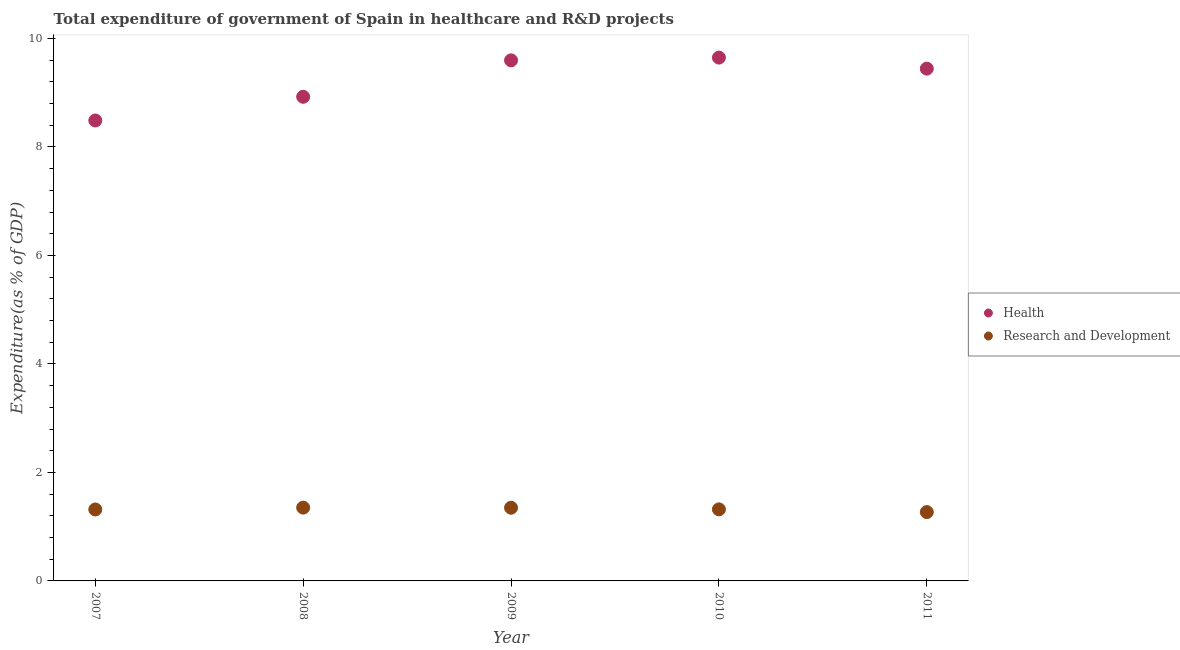What is the expenditure in healthcare in 2010?
Provide a succinct answer. 9.65. Across all years, what is the maximum expenditure in r&d?
Keep it short and to the point. 1.35. Across all years, what is the minimum expenditure in r&d?
Give a very brief answer. 1.27. In which year was the expenditure in r&d minimum?
Your answer should be compact. 2011. What is the total expenditure in healthcare in the graph?
Give a very brief answer. 46.1. What is the difference between the expenditure in r&d in 2008 and that in 2011?
Provide a short and direct response. 0.08. What is the difference between the expenditure in healthcare in 2007 and the expenditure in r&d in 2008?
Your response must be concise. 7.14. What is the average expenditure in healthcare per year?
Give a very brief answer. 9.22. In the year 2008, what is the difference between the expenditure in r&d and expenditure in healthcare?
Ensure brevity in your answer.  -7.57. What is the ratio of the expenditure in r&d in 2009 to that in 2010?
Offer a very short reply. 1.02. Is the difference between the expenditure in healthcare in 2007 and 2011 greater than the difference between the expenditure in r&d in 2007 and 2011?
Keep it short and to the point. No. What is the difference between the highest and the second highest expenditure in healthcare?
Provide a succinct answer. 0.05. What is the difference between the highest and the lowest expenditure in r&d?
Offer a terse response. 0.08. In how many years, is the expenditure in r&d greater than the average expenditure in r&d taken over all years?
Offer a terse response. 2. Is the sum of the expenditure in healthcare in 2007 and 2010 greater than the maximum expenditure in r&d across all years?
Provide a short and direct response. Yes. Is the expenditure in healthcare strictly less than the expenditure in r&d over the years?
Offer a terse response. No. How many years are there in the graph?
Offer a terse response. 5. Does the graph contain any zero values?
Your response must be concise. No. What is the title of the graph?
Provide a succinct answer. Total expenditure of government of Spain in healthcare and R&D projects. Does "Secondary Education" appear as one of the legend labels in the graph?
Your response must be concise. No. What is the label or title of the X-axis?
Provide a succinct answer. Year. What is the label or title of the Y-axis?
Your answer should be compact. Expenditure(as % of GDP). What is the Expenditure(as % of GDP) in Health in 2007?
Offer a terse response. 8.49. What is the Expenditure(as % of GDP) of Research and Development in 2007?
Give a very brief answer. 1.32. What is the Expenditure(as % of GDP) in Health in 2008?
Keep it short and to the point. 8.93. What is the Expenditure(as % of GDP) in Research and Development in 2008?
Offer a very short reply. 1.35. What is the Expenditure(as % of GDP) of Health in 2009?
Provide a succinct answer. 9.6. What is the Expenditure(as % of GDP) in Research and Development in 2009?
Offer a very short reply. 1.35. What is the Expenditure(as % of GDP) in Health in 2010?
Offer a terse response. 9.65. What is the Expenditure(as % of GDP) in Research and Development in 2010?
Provide a succinct answer. 1.32. What is the Expenditure(as % of GDP) of Health in 2011?
Offer a terse response. 9.44. What is the Expenditure(as % of GDP) in Research and Development in 2011?
Your response must be concise. 1.27. Across all years, what is the maximum Expenditure(as % of GDP) of Health?
Your answer should be very brief. 9.65. Across all years, what is the maximum Expenditure(as % of GDP) of Research and Development?
Your answer should be compact. 1.35. Across all years, what is the minimum Expenditure(as % of GDP) of Health?
Ensure brevity in your answer.  8.49. Across all years, what is the minimum Expenditure(as % of GDP) in Research and Development?
Offer a terse response. 1.27. What is the total Expenditure(as % of GDP) of Health in the graph?
Your answer should be very brief. 46.1. What is the total Expenditure(as % of GDP) in Research and Development in the graph?
Offer a terse response. 6.61. What is the difference between the Expenditure(as % of GDP) of Health in 2007 and that in 2008?
Keep it short and to the point. -0.44. What is the difference between the Expenditure(as % of GDP) in Research and Development in 2007 and that in 2008?
Offer a very short reply. -0.03. What is the difference between the Expenditure(as % of GDP) in Health in 2007 and that in 2009?
Give a very brief answer. -1.11. What is the difference between the Expenditure(as % of GDP) of Research and Development in 2007 and that in 2009?
Your answer should be very brief. -0.03. What is the difference between the Expenditure(as % of GDP) in Health in 2007 and that in 2010?
Provide a succinct answer. -1.16. What is the difference between the Expenditure(as % of GDP) of Research and Development in 2007 and that in 2010?
Provide a succinct answer. -0. What is the difference between the Expenditure(as % of GDP) in Health in 2007 and that in 2011?
Make the answer very short. -0.96. What is the difference between the Expenditure(as % of GDP) of Research and Development in 2007 and that in 2011?
Your answer should be very brief. 0.05. What is the difference between the Expenditure(as % of GDP) of Health in 2008 and that in 2009?
Make the answer very short. -0.67. What is the difference between the Expenditure(as % of GDP) of Research and Development in 2008 and that in 2009?
Provide a short and direct response. 0. What is the difference between the Expenditure(as % of GDP) of Health in 2008 and that in 2010?
Provide a succinct answer. -0.72. What is the difference between the Expenditure(as % of GDP) in Research and Development in 2008 and that in 2010?
Keep it short and to the point. 0.03. What is the difference between the Expenditure(as % of GDP) of Health in 2008 and that in 2011?
Make the answer very short. -0.52. What is the difference between the Expenditure(as % of GDP) in Research and Development in 2008 and that in 2011?
Your response must be concise. 0.08. What is the difference between the Expenditure(as % of GDP) of Health in 2009 and that in 2010?
Keep it short and to the point. -0.05. What is the difference between the Expenditure(as % of GDP) of Research and Development in 2009 and that in 2010?
Keep it short and to the point. 0.03. What is the difference between the Expenditure(as % of GDP) in Health in 2009 and that in 2011?
Provide a short and direct response. 0.15. What is the difference between the Expenditure(as % of GDP) in Research and Development in 2009 and that in 2011?
Provide a succinct answer. 0.08. What is the difference between the Expenditure(as % of GDP) of Health in 2010 and that in 2011?
Offer a terse response. 0.2. What is the difference between the Expenditure(as % of GDP) of Research and Development in 2010 and that in 2011?
Your answer should be compact. 0.05. What is the difference between the Expenditure(as % of GDP) in Health in 2007 and the Expenditure(as % of GDP) in Research and Development in 2008?
Provide a short and direct response. 7.14. What is the difference between the Expenditure(as % of GDP) of Health in 2007 and the Expenditure(as % of GDP) of Research and Development in 2009?
Provide a succinct answer. 7.14. What is the difference between the Expenditure(as % of GDP) in Health in 2007 and the Expenditure(as % of GDP) in Research and Development in 2010?
Ensure brevity in your answer.  7.17. What is the difference between the Expenditure(as % of GDP) of Health in 2007 and the Expenditure(as % of GDP) of Research and Development in 2011?
Keep it short and to the point. 7.22. What is the difference between the Expenditure(as % of GDP) of Health in 2008 and the Expenditure(as % of GDP) of Research and Development in 2009?
Provide a short and direct response. 7.58. What is the difference between the Expenditure(as % of GDP) in Health in 2008 and the Expenditure(as % of GDP) in Research and Development in 2010?
Your response must be concise. 7.61. What is the difference between the Expenditure(as % of GDP) in Health in 2008 and the Expenditure(as % of GDP) in Research and Development in 2011?
Your answer should be very brief. 7.66. What is the difference between the Expenditure(as % of GDP) in Health in 2009 and the Expenditure(as % of GDP) in Research and Development in 2010?
Give a very brief answer. 8.28. What is the difference between the Expenditure(as % of GDP) in Health in 2009 and the Expenditure(as % of GDP) in Research and Development in 2011?
Your response must be concise. 8.33. What is the difference between the Expenditure(as % of GDP) of Health in 2010 and the Expenditure(as % of GDP) of Research and Development in 2011?
Provide a short and direct response. 8.38. What is the average Expenditure(as % of GDP) in Health per year?
Provide a short and direct response. 9.22. What is the average Expenditure(as % of GDP) in Research and Development per year?
Provide a short and direct response. 1.32. In the year 2007, what is the difference between the Expenditure(as % of GDP) of Health and Expenditure(as % of GDP) of Research and Development?
Your answer should be compact. 7.17. In the year 2008, what is the difference between the Expenditure(as % of GDP) of Health and Expenditure(as % of GDP) of Research and Development?
Your answer should be very brief. 7.57. In the year 2009, what is the difference between the Expenditure(as % of GDP) of Health and Expenditure(as % of GDP) of Research and Development?
Keep it short and to the point. 8.25. In the year 2010, what is the difference between the Expenditure(as % of GDP) in Health and Expenditure(as % of GDP) in Research and Development?
Keep it short and to the point. 8.33. In the year 2011, what is the difference between the Expenditure(as % of GDP) of Health and Expenditure(as % of GDP) of Research and Development?
Provide a short and direct response. 8.18. What is the ratio of the Expenditure(as % of GDP) of Health in 2007 to that in 2008?
Offer a terse response. 0.95. What is the ratio of the Expenditure(as % of GDP) of Research and Development in 2007 to that in 2008?
Provide a short and direct response. 0.97. What is the ratio of the Expenditure(as % of GDP) of Health in 2007 to that in 2009?
Keep it short and to the point. 0.88. What is the ratio of the Expenditure(as % of GDP) in Research and Development in 2007 to that in 2009?
Provide a succinct answer. 0.98. What is the ratio of the Expenditure(as % of GDP) in Health in 2007 to that in 2010?
Ensure brevity in your answer.  0.88. What is the ratio of the Expenditure(as % of GDP) in Research and Development in 2007 to that in 2010?
Your response must be concise. 1. What is the ratio of the Expenditure(as % of GDP) of Health in 2007 to that in 2011?
Keep it short and to the point. 0.9. What is the ratio of the Expenditure(as % of GDP) in Research and Development in 2007 to that in 2011?
Your response must be concise. 1.04. What is the ratio of the Expenditure(as % of GDP) in Health in 2008 to that in 2009?
Your answer should be very brief. 0.93. What is the ratio of the Expenditure(as % of GDP) of Health in 2008 to that in 2010?
Your answer should be very brief. 0.93. What is the ratio of the Expenditure(as % of GDP) in Research and Development in 2008 to that in 2010?
Provide a short and direct response. 1.02. What is the ratio of the Expenditure(as % of GDP) of Health in 2008 to that in 2011?
Make the answer very short. 0.94. What is the ratio of the Expenditure(as % of GDP) of Research and Development in 2008 to that in 2011?
Your answer should be very brief. 1.06. What is the ratio of the Expenditure(as % of GDP) in Health in 2009 to that in 2011?
Provide a short and direct response. 1.02. What is the ratio of the Expenditure(as % of GDP) of Research and Development in 2009 to that in 2011?
Offer a terse response. 1.06. What is the ratio of the Expenditure(as % of GDP) of Health in 2010 to that in 2011?
Provide a short and direct response. 1.02. What is the ratio of the Expenditure(as % of GDP) of Research and Development in 2010 to that in 2011?
Provide a succinct answer. 1.04. What is the difference between the highest and the second highest Expenditure(as % of GDP) in Health?
Keep it short and to the point. 0.05. What is the difference between the highest and the second highest Expenditure(as % of GDP) in Research and Development?
Your answer should be very brief. 0. What is the difference between the highest and the lowest Expenditure(as % of GDP) in Health?
Make the answer very short. 1.16. What is the difference between the highest and the lowest Expenditure(as % of GDP) of Research and Development?
Provide a succinct answer. 0.08. 